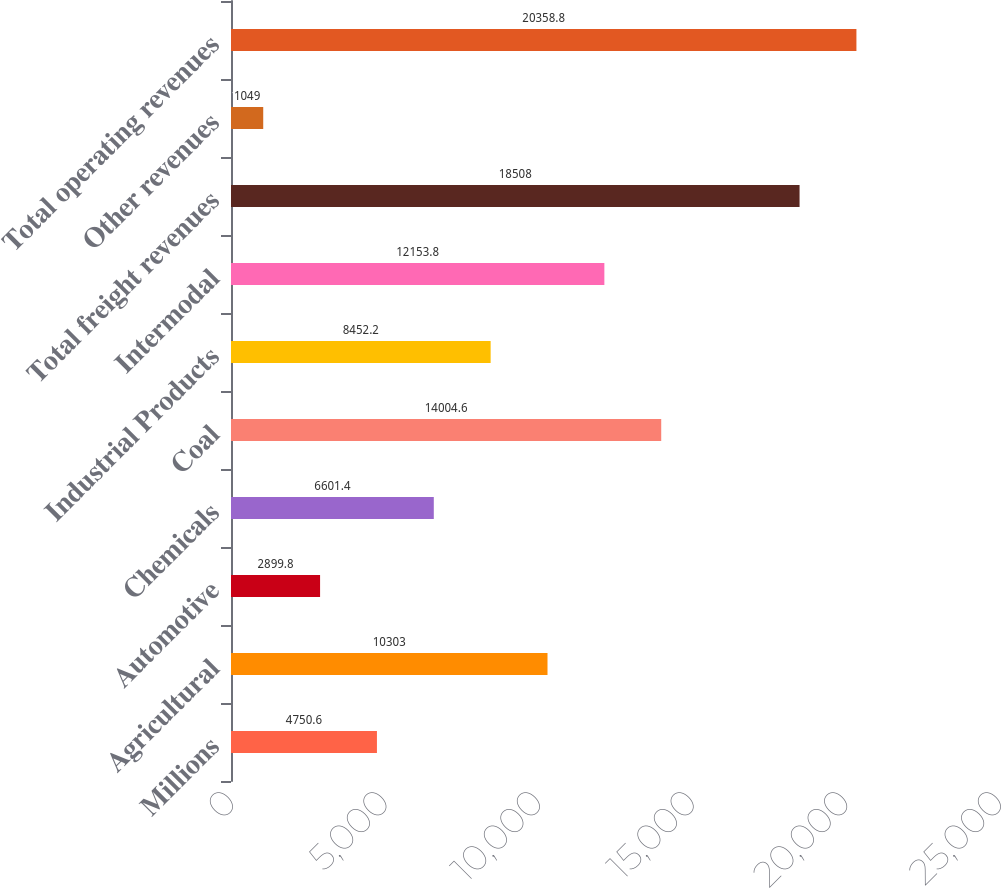Convert chart. <chart><loc_0><loc_0><loc_500><loc_500><bar_chart><fcel>Millions<fcel>Agricultural<fcel>Automotive<fcel>Chemicals<fcel>Coal<fcel>Industrial Products<fcel>Intermodal<fcel>Total freight revenues<fcel>Other revenues<fcel>Total operating revenues<nl><fcel>4750.6<fcel>10303<fcel>2899.8<fcel>6601.4<fcel>14004.6<fcel>8452.2<fcel>12153.8<fcel>18508<fcel>1049<fcel>20358.8<nl></chart> 